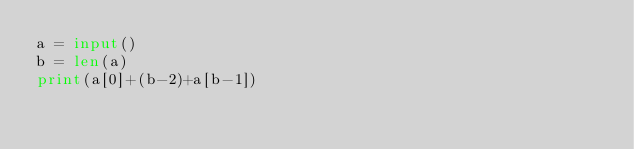Convert code to text. <code><loc_0><loc_0><loc_500><loc_500><_Python_>a = input()
b = len(a)
print(a[0]+(b-2)+a[b-1])</code> 